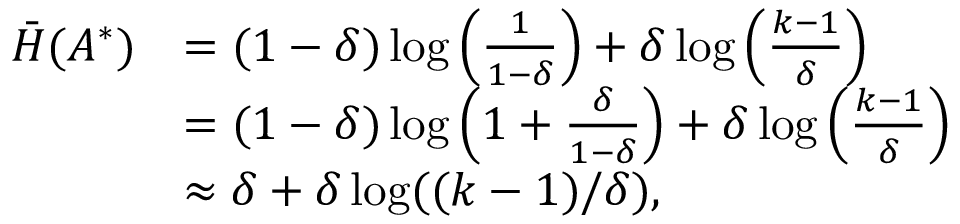Convert formula to latex. <formula><loc_0><loc_0><loc_500><loc_500>\begin{array} { r l } { \bar { H } ( A ^ { * } ) } & { = ( 1 - \delta ) \log \left ( \frac { 1 } { 1 - \delta } \right ) + \delta \log \left ( \frac { k - 1 } { \delta } \right ) } \\ & { = ( 1 - \delta ) \log \left ( 1 + \frac { \delta } { 1 - \delta } \right ) + \delta \log \left ( \frac { k - 1 } { \delta } \right ) } \\ & { \approx \delta + \delta \log ( ( k - 1 ) / \delta ) , } \end{array}</formula> 